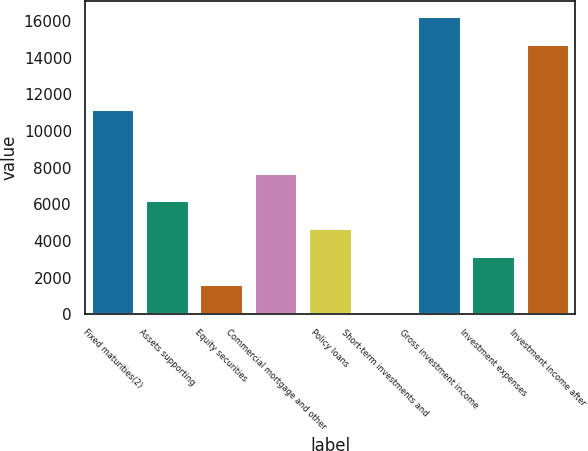Convert chart. <chart><loc_0><loc_0><loc_500><loc_500><bar_chart><fcel>Fixed maturities(2)<fcel>Assets supporting<fcel>Equity securities<fcel>Commercial mortgage and other<fcel>Policy loans<fcel>Short-term investments and<fcel>Gross investment income<fcel>Investment expenses<fcel>Investment income after<nl><fcel>11211<fcel>6217.6<fcel>1660.9<fcel>7736.5<fcel>4698.7<fcel>142<fcel>16280.9<fcel>3179.8<fcel>14762<nl></chart> 